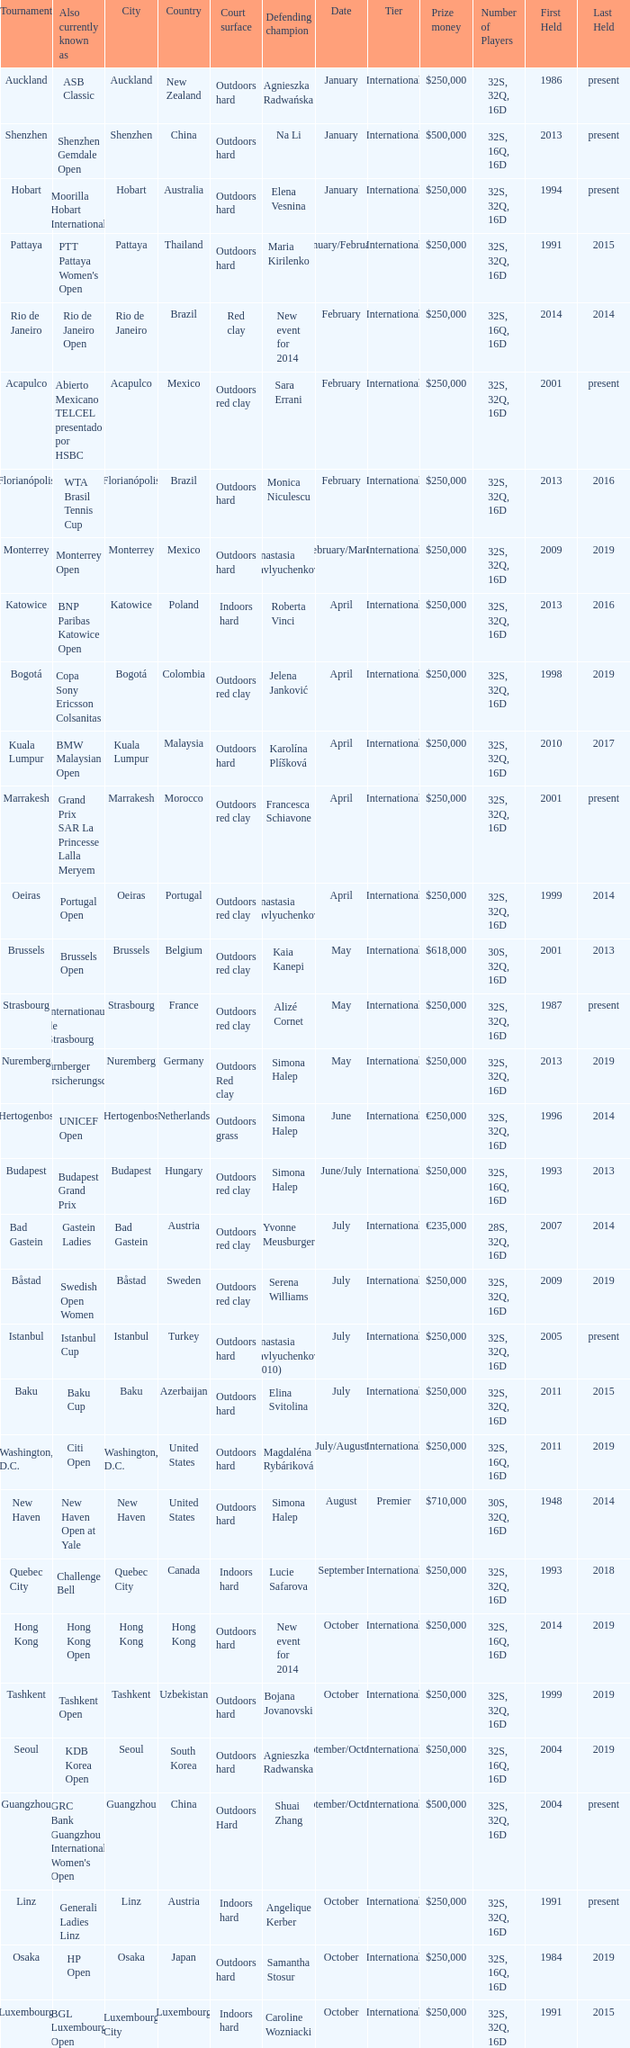How many tournaments are also currently known as the hp open? 1.0. 